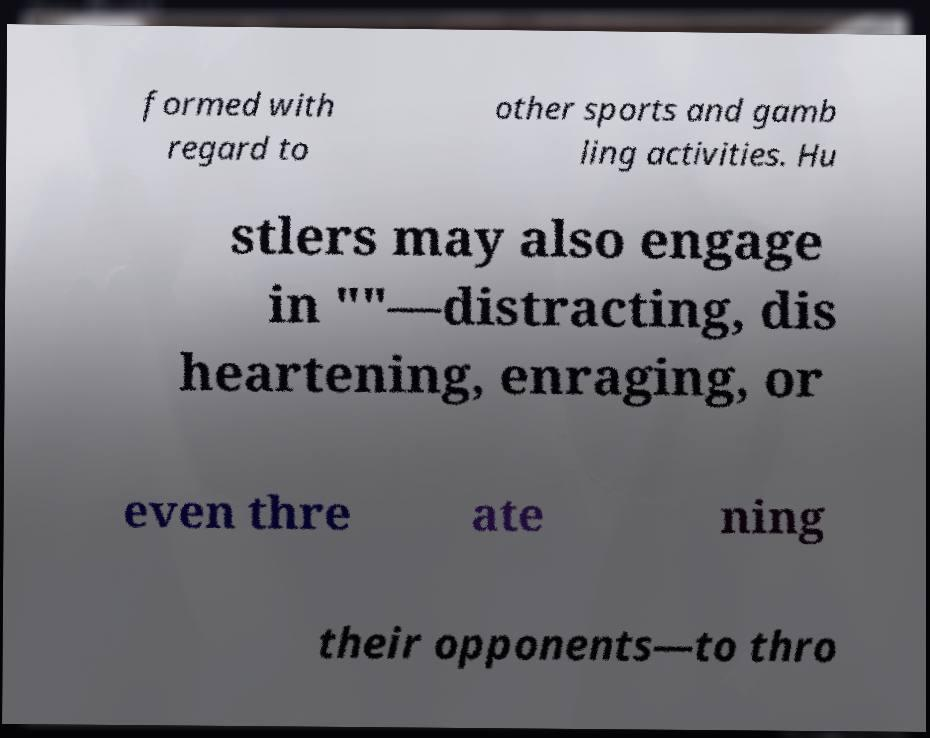Can you read and provide the text displayed in the image?This photo seems to have some interesting text. Can you extract and type it out for me? formed with regard to other sports and gamb ling activities. Hu stlers may also engage in ""—distracting, dis heartening, enraging, or even thre ate ning their opponents—to thro 